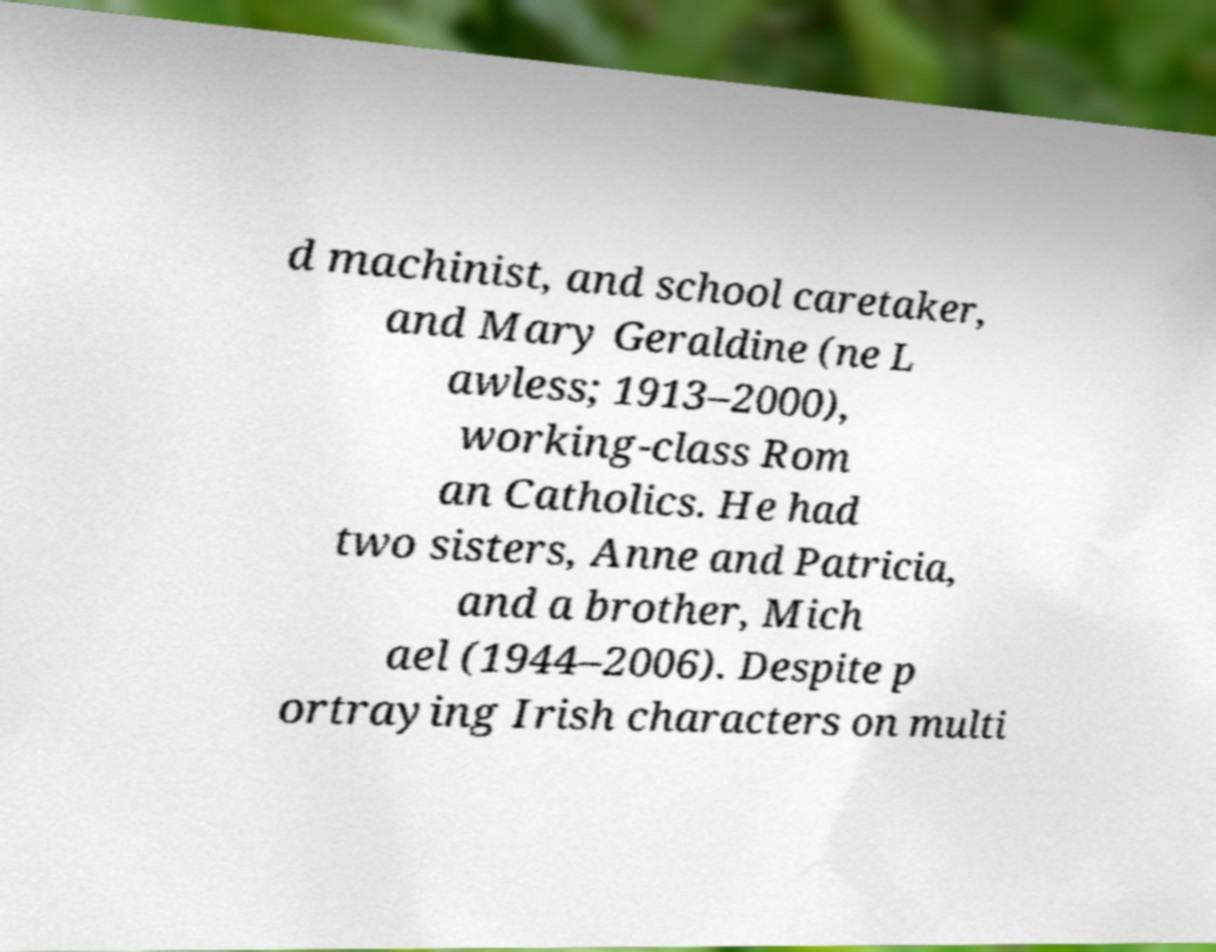Please read and relay the text visible in this image. What does it say? d machinist, and school caretaker, and Mary Geraldine (ne L awless; 1913–2000), working-class Rom an Catholics. He had two sisters, Anne and Patricia, and a brother, Mich ael (1944–2006). Despite p ortraying Irish characters on multi 